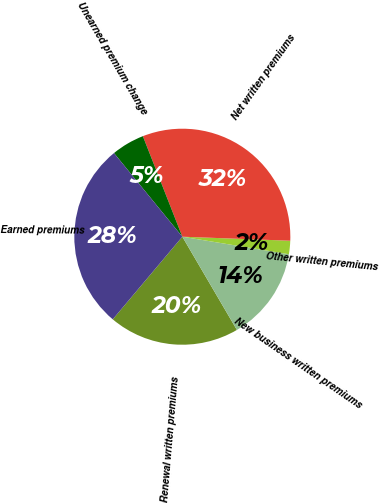<chart> <loc_0><loc_0><loc_500><loc_500><pie_chart><fcel>Renewal written premiums<fcel>New business written premiums<fcel>Other written premiums<fcel>Net written premiums<fcel>Unearned premium change<fcel>Earned premiums<nl><fcel>19.57%<fcel>13.98%<fcel>2.0%<fcel>31.55%<fcel>4.95%<fcel>27.96%<nl></chart> 